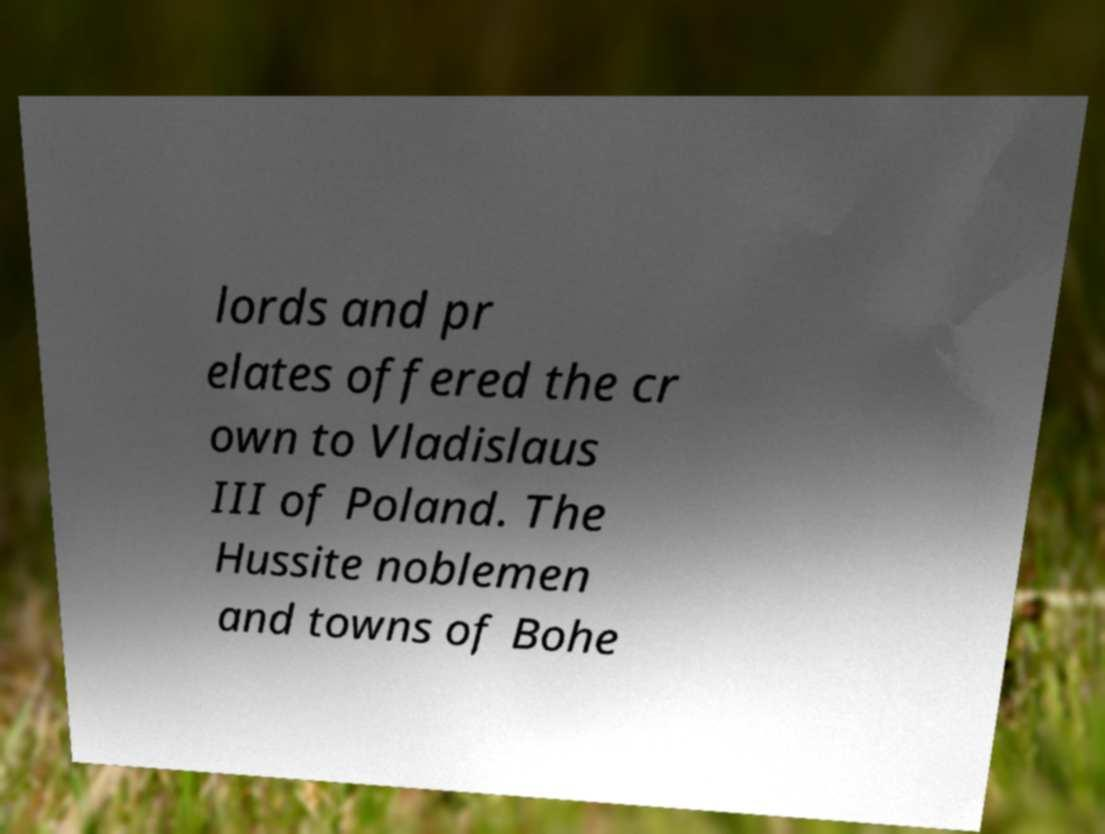There's text embedded in this image that I need extracted. Can you transcribe it verbatim? lords and pr elates offered the cr own to Vladislaus III of Poland. The Hussite noblemen and towns of Bohe 